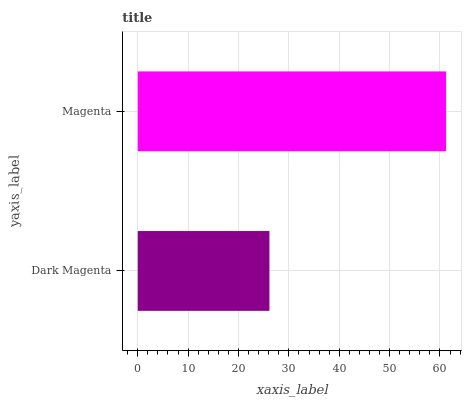Is Dark Magenta the minimum?
Answer yes or no. Yes. Is Magenta the maximum?
Answer yes or no. Yes. Is Magenta the minimum?
Answer yes or no. No. Is Magenta greater than Dark Magenta?
Answer yes or no. Yes. Is Dark Magenta less than Magenta?
Answer yes or no. Yes. Is Dark Magenta greater than Magenta?
Answer yes or no. No. Is Magenta less than Dark Magenta?
Answer yes or no. No. Is Magenta the high median?
Answer yes or no. Yes. Is Dark Magenta the low median?
Answer yes or no. Yes. Is Dark Magenta the high median?
Answer yes or no. No. Is Magenta the low median?
Answer yes or no. No. 